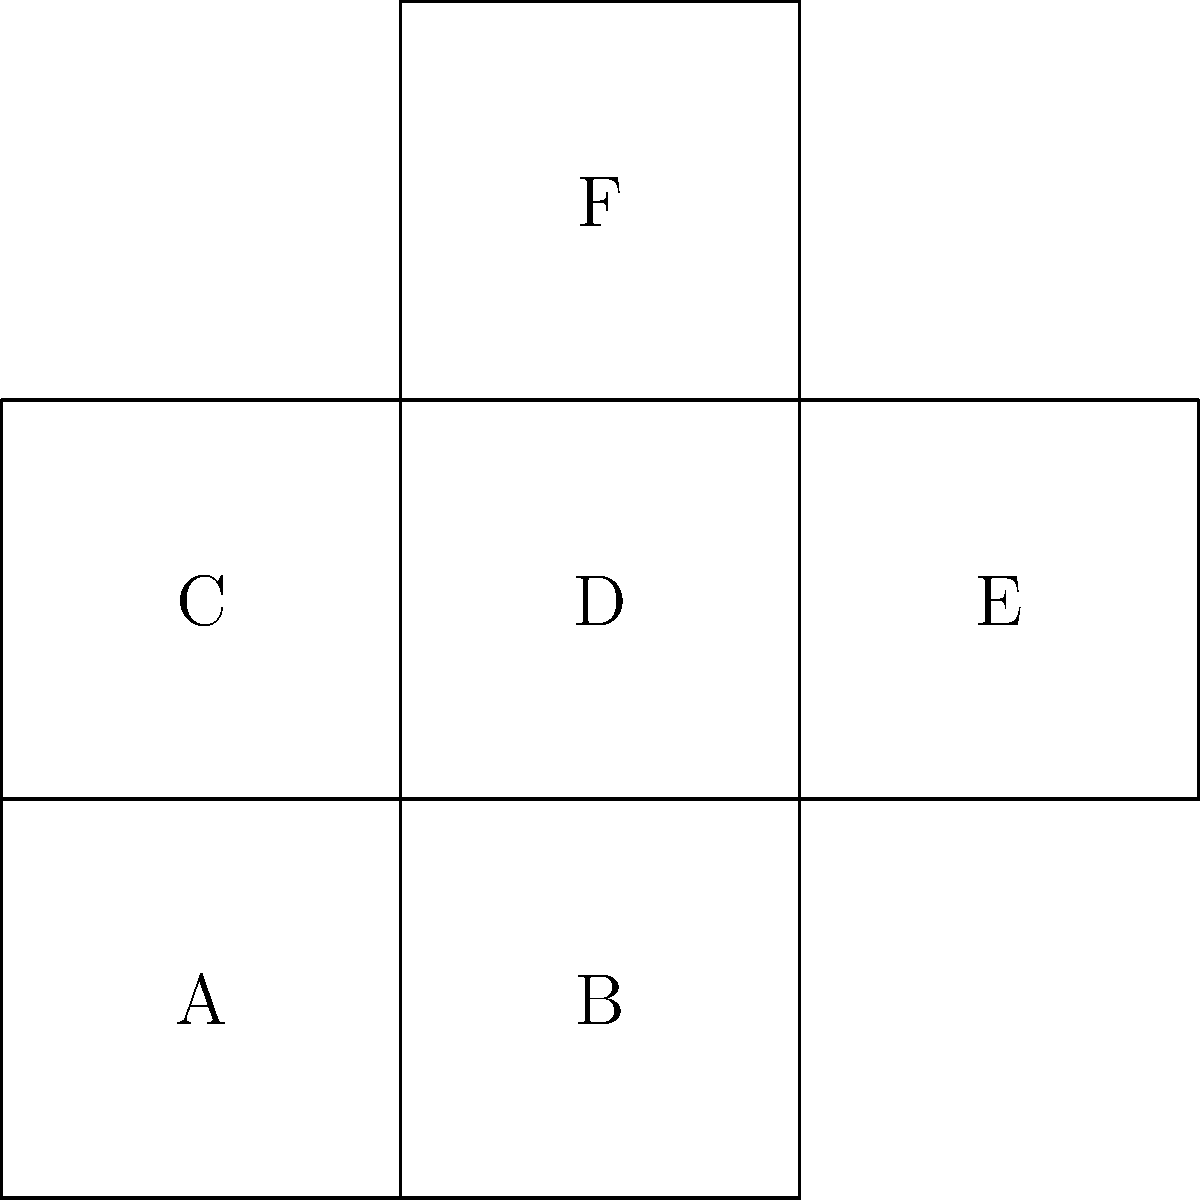As a social scientist studying spatial cognition, you're designing an experiment involving 3D shape recognition. Given the 2D net of a cube shown on the left, which face will be opposite to face A when the cube is folded? Refer to the labeled faces in your answer. To determine which face will be opposite to face A when the cube is folded, we need to follow these steps:

1. Identify the central face: In this net, face D is the central face, as it's connected to four other faces.

2. Locate face A: Face A is adjacent to face D on the bottom.

3. Identify the opposite face: The face opposite to A will be the one that's not adjacent to face D and is on the opposite side of the central face.

4. Analyze the net:
   - Faces B, C, and E are adjacent to face D.
   - Face F is the only face not adjacent to D and is on the opposite side of the central face.

5. Visualize the folding:
   - When folded, face A will form the bottom of the cube.
   - Face F will end up on top, directly opposite to face A.

Therefore, when the cube is folded, face F will be opposite to face A.
Answer: F 